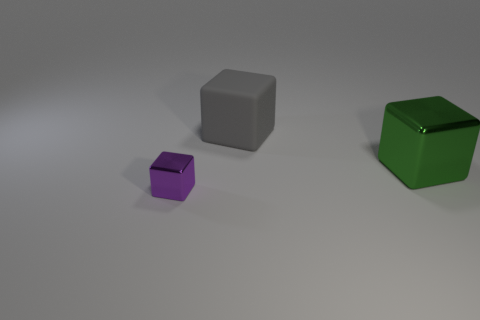Are there any other objects in the image besides the green and purple cubes? Yes, there is also a gray cube in the image. It is positioned between the green and purple cubes and is larger than the purple cube but smaller than the green cube. Do the cubes seem to be made of the same material? It's not possible to determine the exact materials from the image alone, but the light reflections and shadows on the surfaces suggest that all the cubes could be made from matte substances, possibly metal or plastic. 